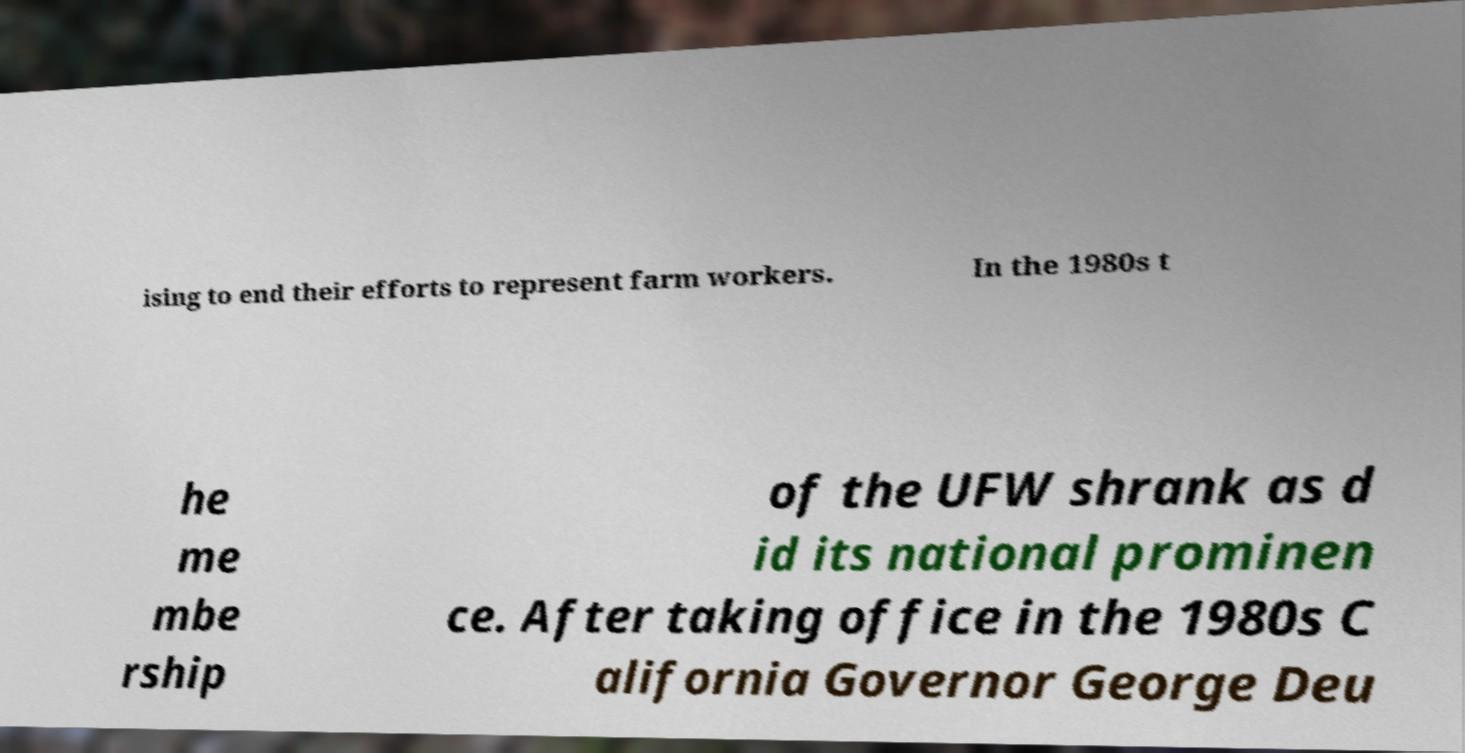For documentation purposes, I need the text within this image transcribed. Could you provide that? ising to end their efforts to represent farm workers. In the 1980s t he me mbe rship of the UFW shrank as d id its national prominen ce. After taking office in the 1980s C alifornia Governor George Deu 